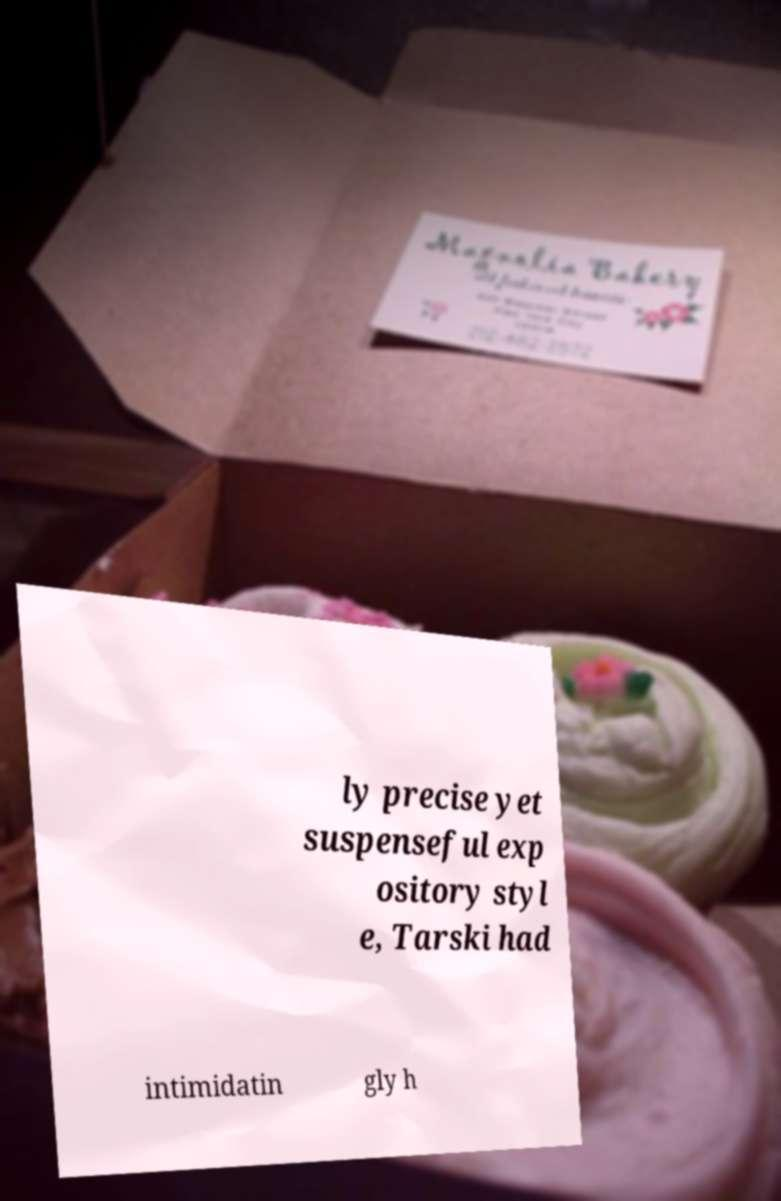There's text embedded in this image that I need extracted. Can you transcribe it verbatim? ly precise yet suspenseful exp ository styl e, Tarski had intimidatin gly h 